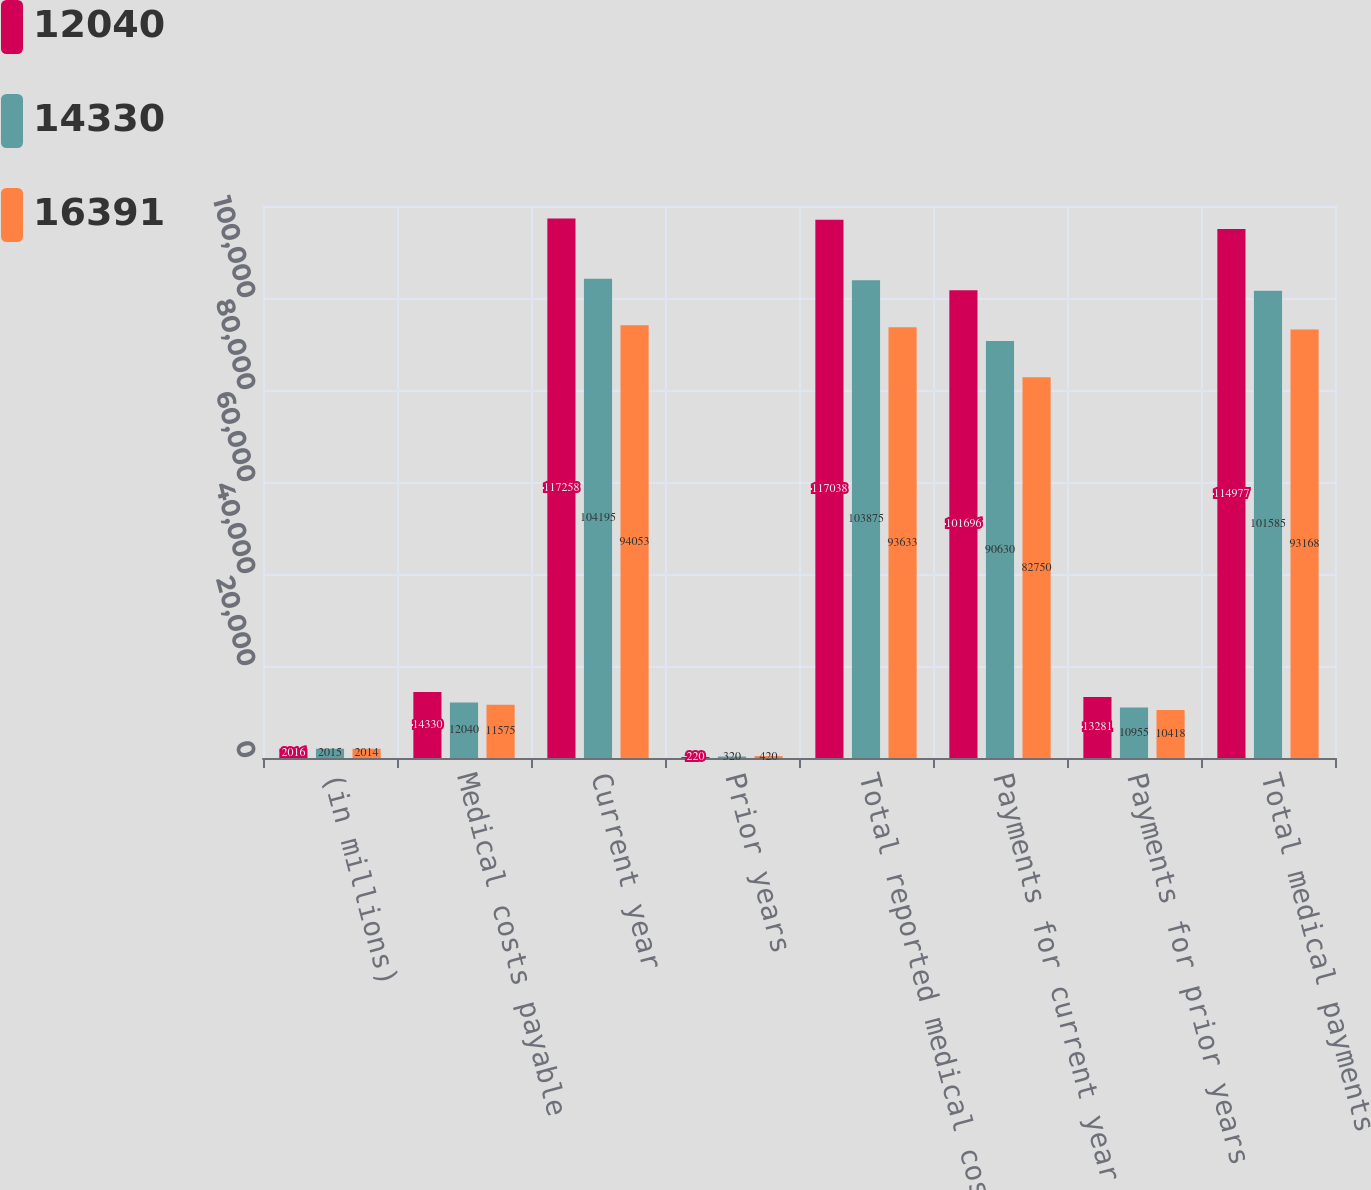Convert chart to OTSL. <chart><loc_0><loc_0><loc_500><loc_500><stacked_bar_chart><ecel><fcel>(in millions)<fcel>Medical costs payable<fcel>Current year<fcel>Prior years<fcel>Total reported medical costs<fcel>Payments for current year<fcel>Payments for prior years<fcel>Total medical payments<nl><fcel>12040<fcel>2016<fcel>14330<fcel>117258<fcel>220<fcel>117038<fcel>101696<fcel>13281<fcel>114977<nl><fcel>14330<fcel>2015<fcel>12040<fcel>104195<fcel>320<fcel>103875<fcel>90630<fcel>10955<fcel>101585<nl><fcel>16391<fcel>2014<fcel>11575<fcel>94053<fcel>420<fcel>93633<fcel>82750<fcel>10418<fcel>93168<nl></chart> 